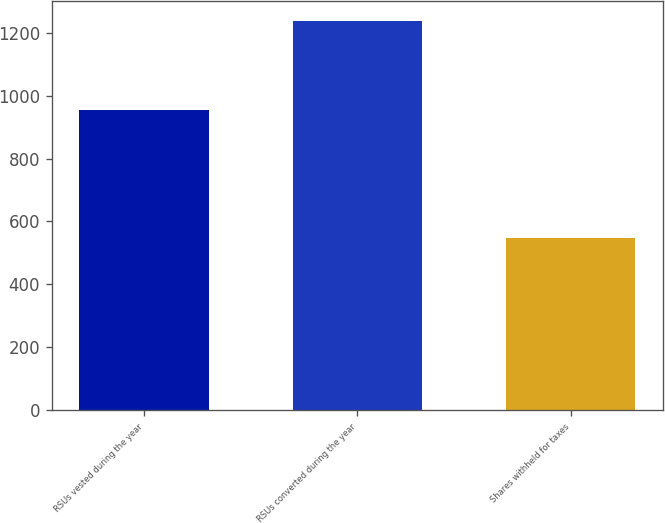<chart> <loc_0><loc_0><loc_500><loc_500><bar_chart><fcel>RSUs vested during the year<fcel>RSUs converted during the year<fcel>Shares withheld for taxes<nl><fcel>954<fcel>1238<fcel>549<nl></chart> 